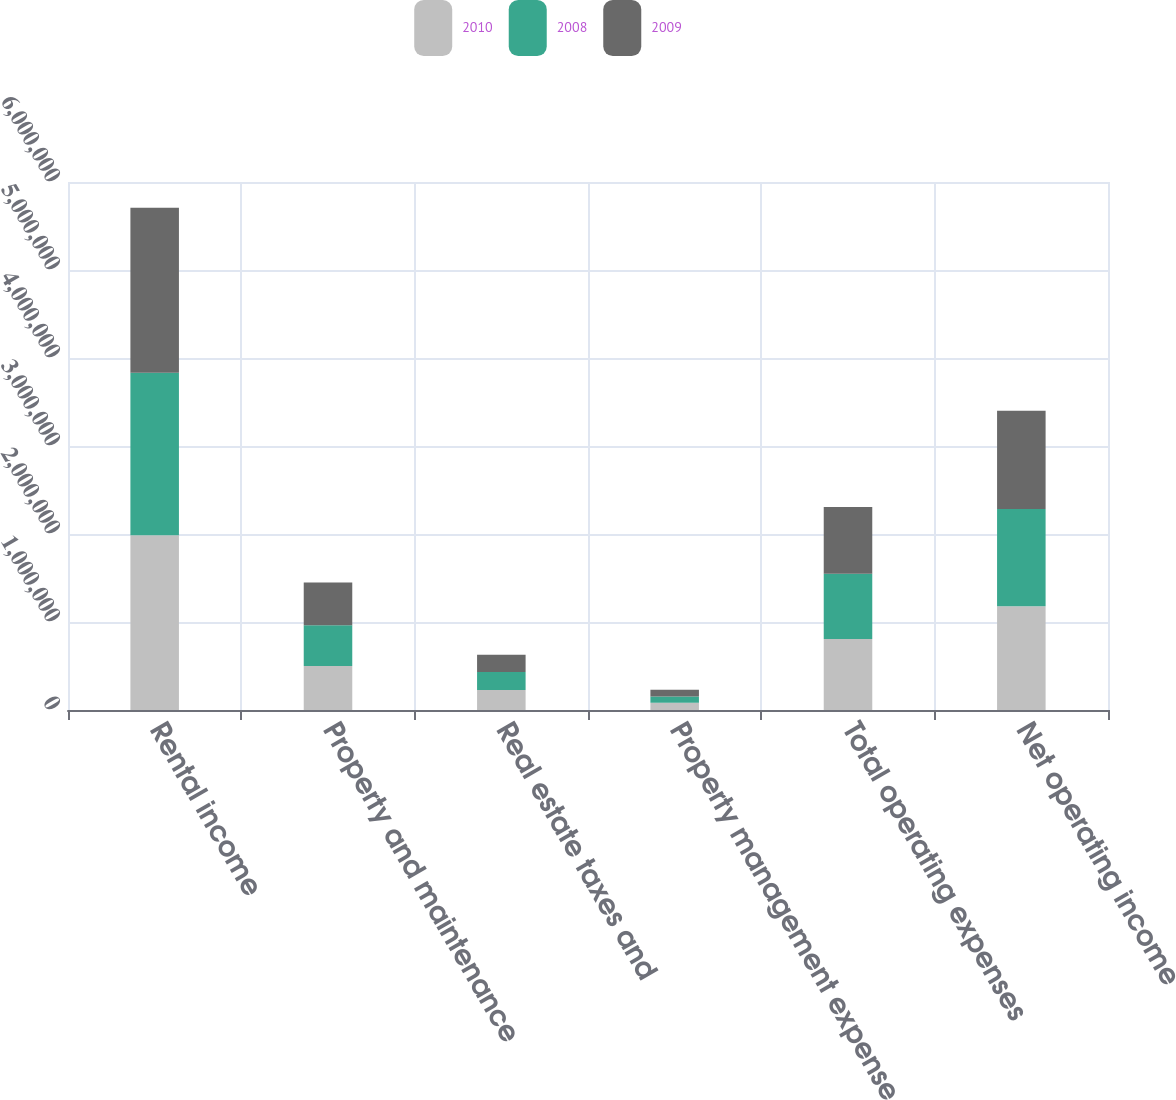<chart> <loc_0><loc_0><loc_500><loc_500><stacked_bar_chart><ecel><fcel>Rental income<fcel>Property and maintenance<fcel>Real estate taxes and<fcel>Property management expense<fcel>Total operating expenses<fcel>Net operating income<nl><fcel>2010<fcel>1.98604e+06<fcel>498634<fcel>226718<fcel>81126<fcel>806478<fcel>1.17956e+06<nl><fcel>2008<fcel>1.84616e+06<fcel>464809<fcel>206247<fcel>71938<fcel>742994<fcel>1.10316e+06<nl><fcel>2009<fcel>1.87627e+06<fcel>485754<fcel>194671<fcel>77063<fcel>757488<fcel>1.11878e+06<nl></chart> 